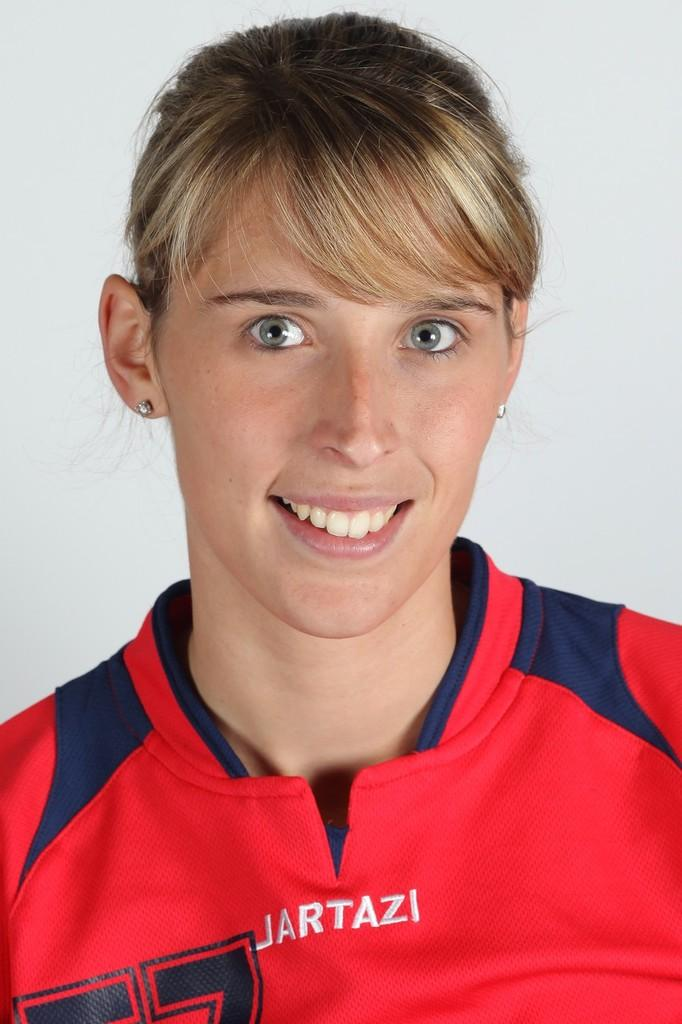Who is present in the image? There is a woman in the image. What is the woman wearing? The woman is wearing a red and blue t-shirt. What is the woman's facial expression? The woman is smiling. What can be seen written or printed in the image? There is a word visible in the image. What color is the background of the image? The background of the image is white. How many legs does the plant have in the image? There is no plant present in the image, so it is not possible to determine the number of legs it might have. 